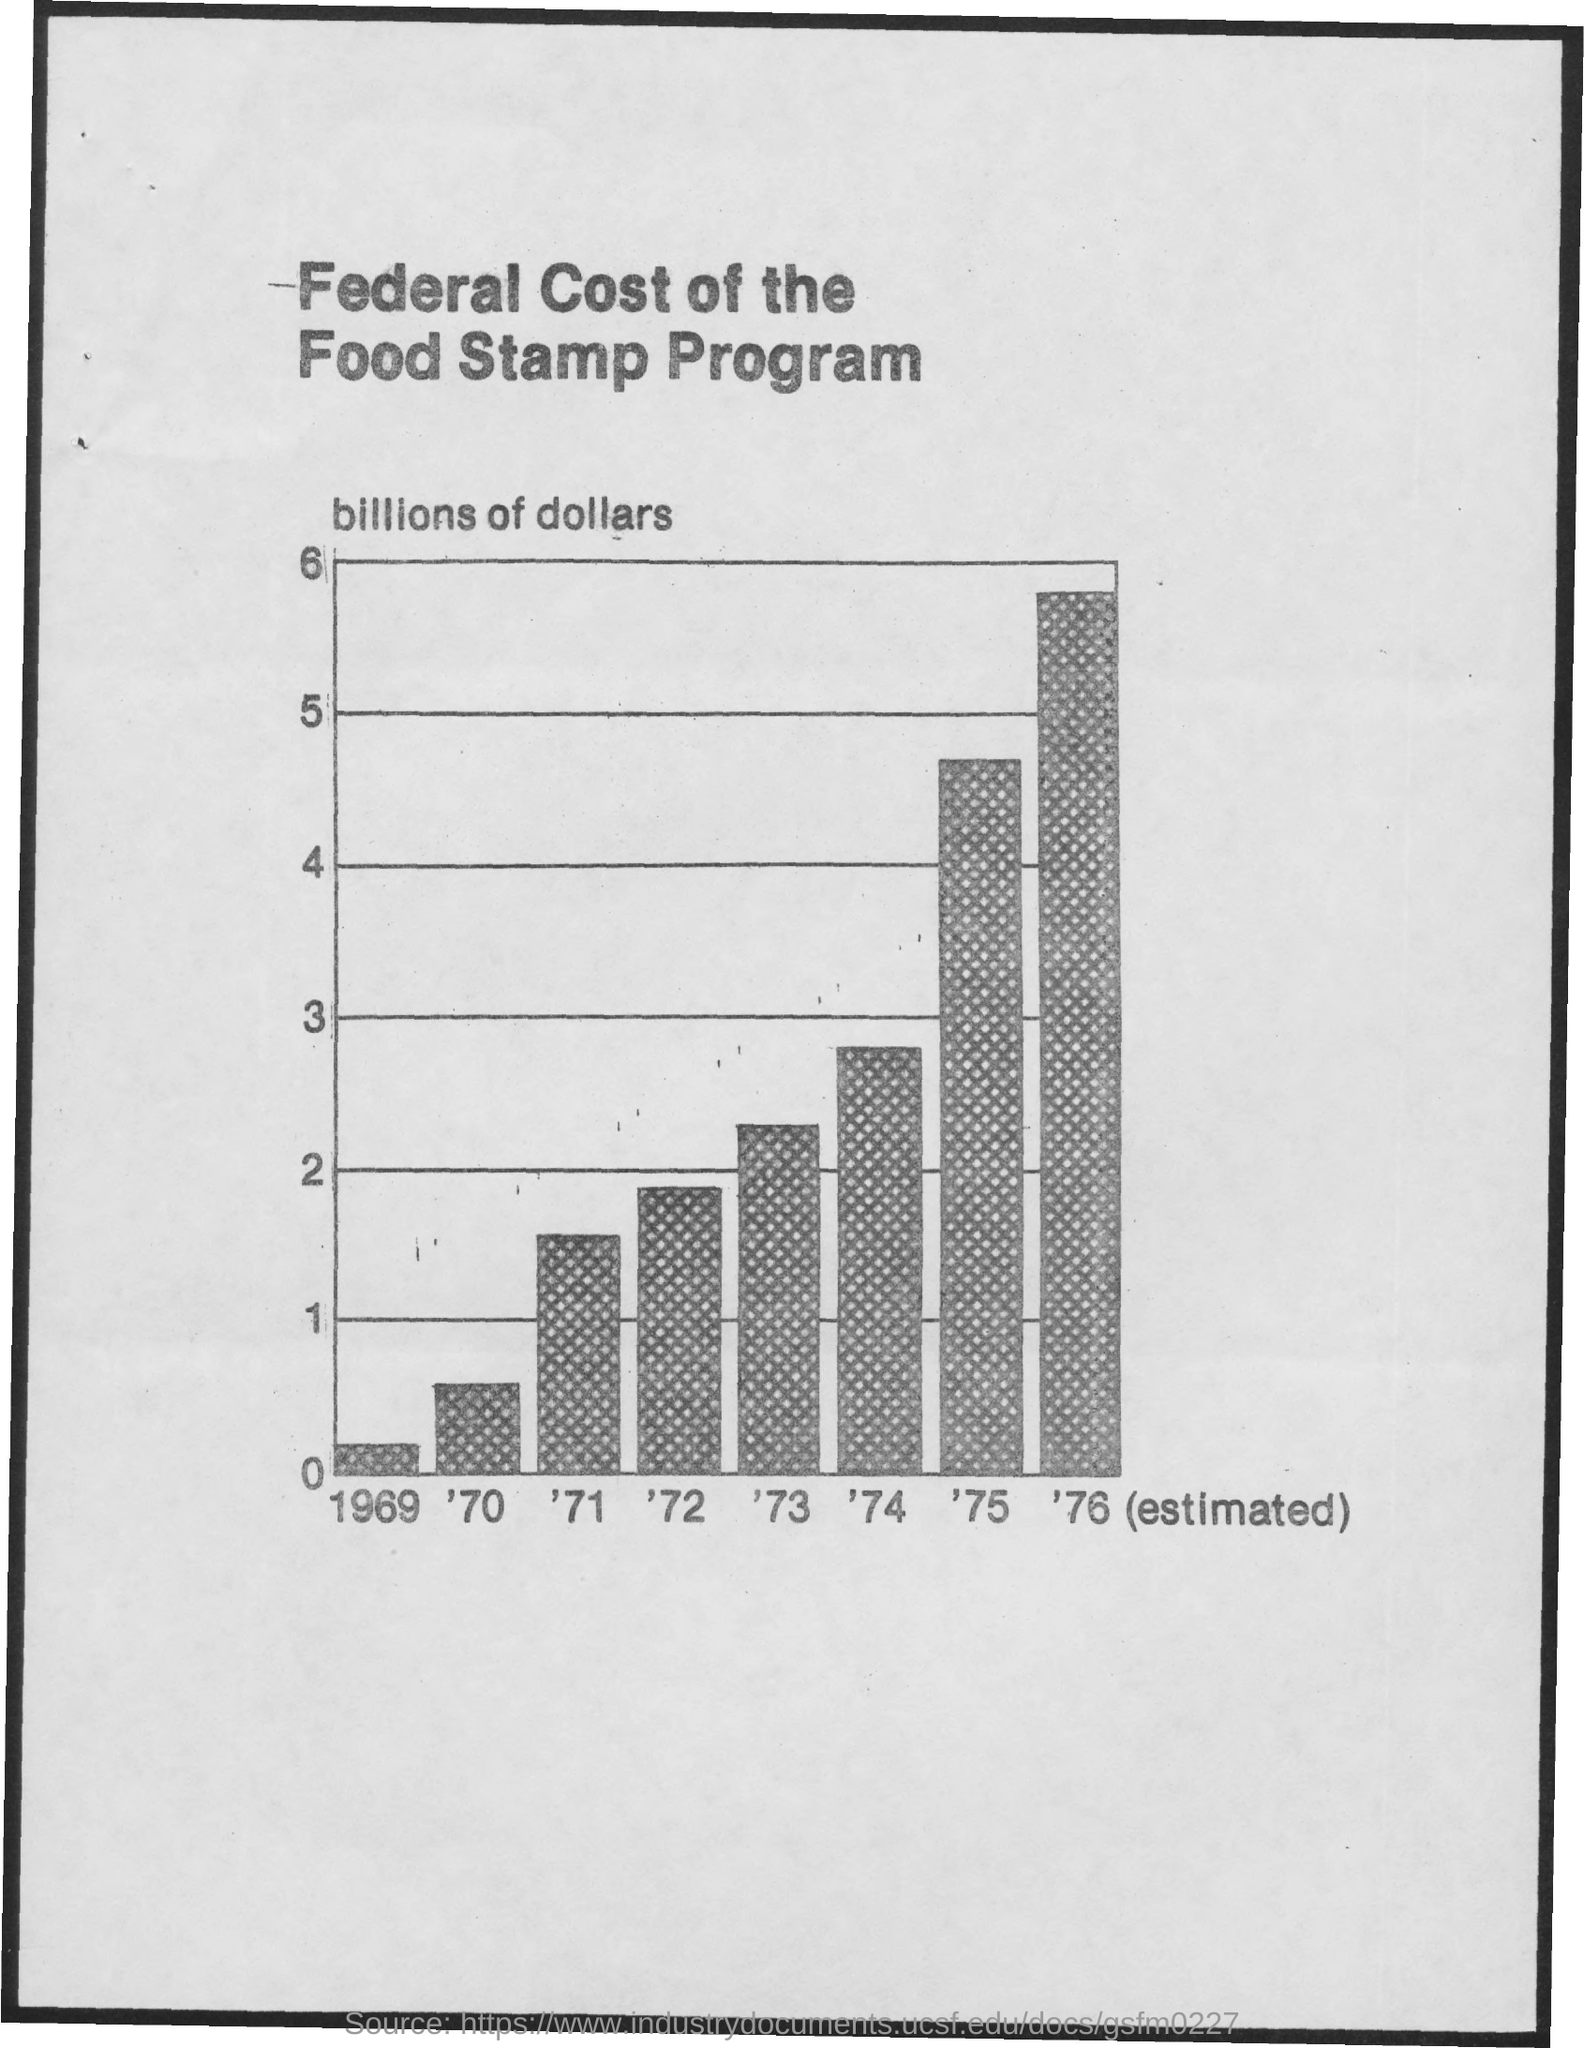Mention a couple of crucial points in this snapshot. The lowest value was in 1969. The second lowest value is in which year? '70. The highest value was in 1976 The title of the document is 'Federal cost of the food stamp program.' The third highest value is from 1974. 